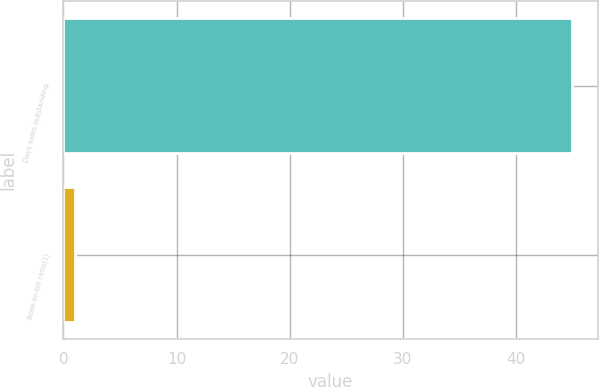Convert chart. <chart><loc_0><loc_0><loc_500><loc_500><bar_chart><fcel>Days sales outstanding<fcel>Book-to-bill ratio(2)<nl><fcel>45<fcel>1<nl></chart> 